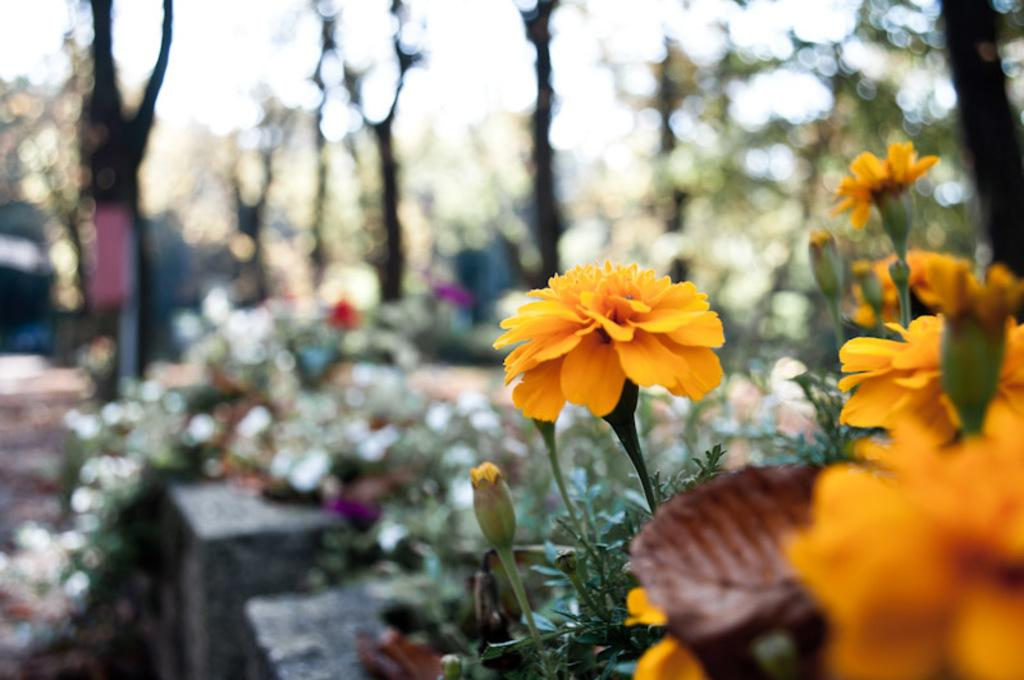What types of living organisms can be seen in the image? Plants and flowers are visible in the image. Can you describe the background of the image? The background of the image is blurred. What type of respect can be seen in the image? There is no indication of respect in the image, as it features plants and flowers. What type of health benefits can be gained from the picture? The image is not a picture of a health supplement or exercise routine, so it cannot be associated with health benefits. 